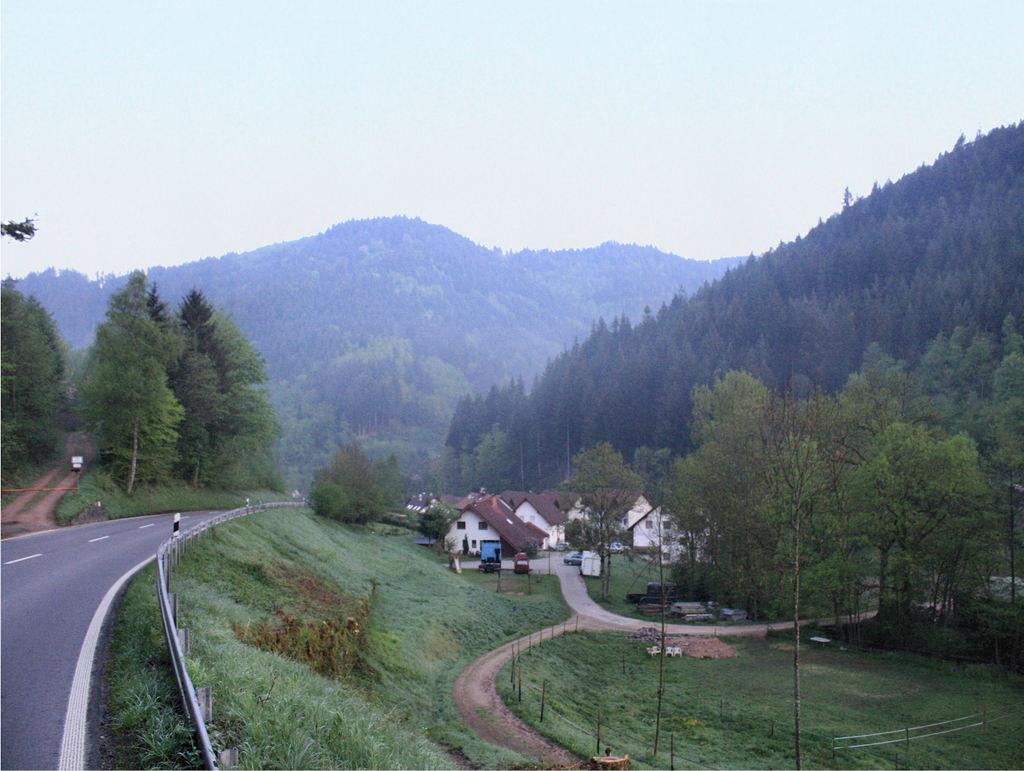What type of structures are visible in the image? There are houses in the image. What type of vegetation can be seen in the image? There are trees and grass in the image. What type of pathway is present in the image? There is a road in the image. What can be seen in the background of the image? There are mountains in the background of the image. What is visible at the top of the image? The sky is visible at the top of the image. Can you tell me how many tigers are walking on the road in the image? There are no tigers present in the image; it features houses, trees, grass, a road, mountains, and the sky. What type of operation is being performed on the houses in the image? There is no operation being performed on the houses in the image; they are simply standing in the scene. 